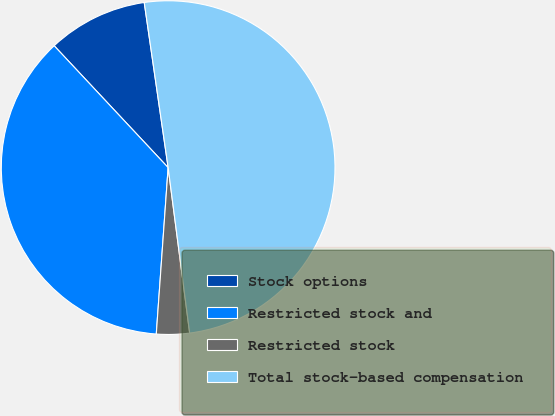Convert chart. <chart><loc_0><loc_0><loc_500><loc_500><pie_chart><fcel>Stock options<fcel>Restricted stock and<fcel>Restricted stock<fcel>Total stock-based compensation<nl><fcel>9.68%<fcel>36.9%<fcel>3.19%<fcel>50.23%<nl></chart> 